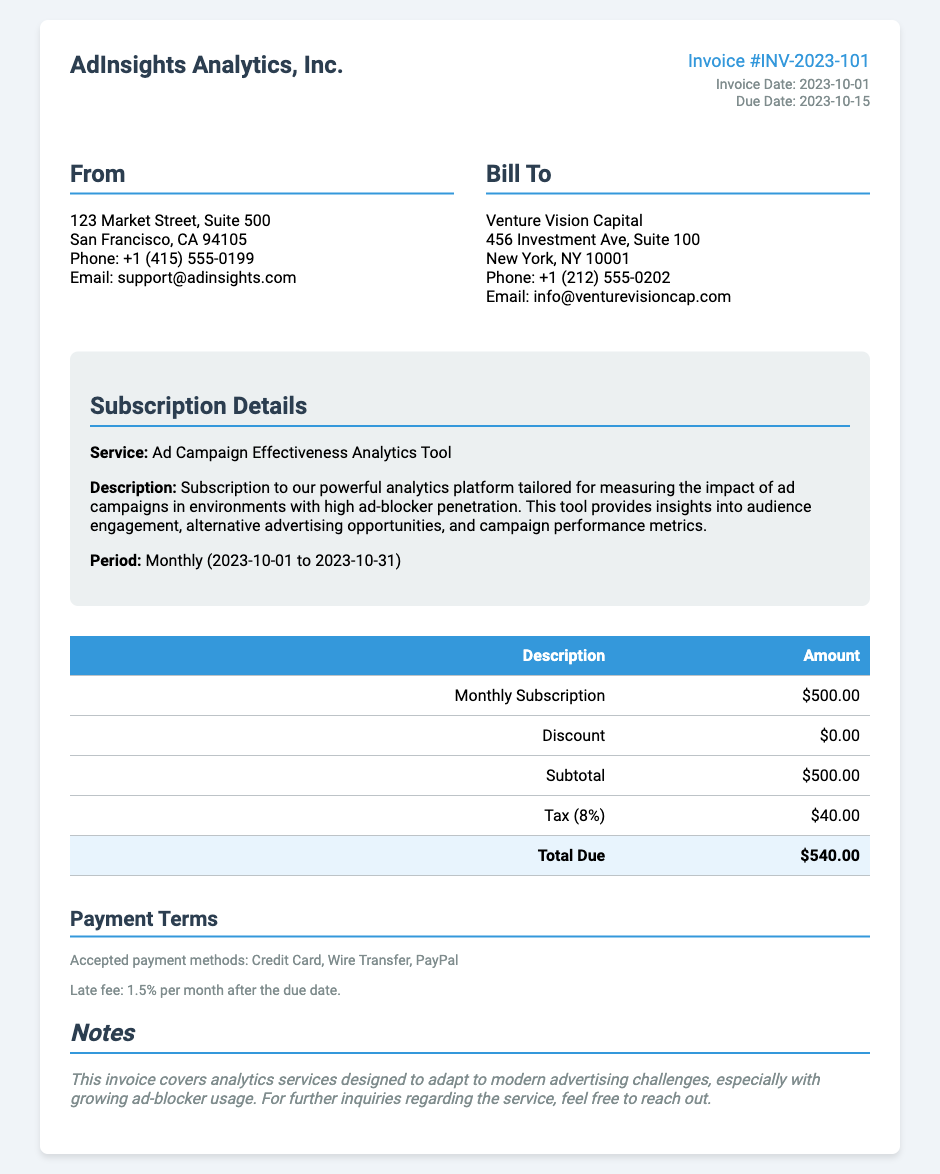What is the invoice number? The invoice number is explicitly stated in the document for easy reference.
Answer: INV-2023-101 What is the invoice date? The invoice date indicates when the bill was generated and is clearly listed in the document.
Answer: 2023-10-01 What is the amount for the monthly subscription? The document specifies the amount charged for the monthly subscription service.
Answer: $500.00 What is the total due amount? The total due reflects the final amount that needs to be paid, after tax and any discounts.
Answer: $540.00 What payment methods are accepted? The document mentions accepted payment methods, providing options for the client.
Answer: Credit Card, Wire Transfer, PayPal What is the due date for the invoice? The due date indicates when the payment is expected, which is provided in the document.
Answer: 2023-10-15 What service is being billed? The service described gives a clear understanding of what the subscription covers, tailored for specific needs.
Answer: Ad Campaign Effectiveness Analytics Tool What is the tax percentage applied? The tax percentage is specified in the document, indicating how much tax was added to the subtotal.
Answer: 8% What late fee is applicable? The document explicitly states the consequences of late payment, outlining additional costs.
Answer: 1.5% per month 